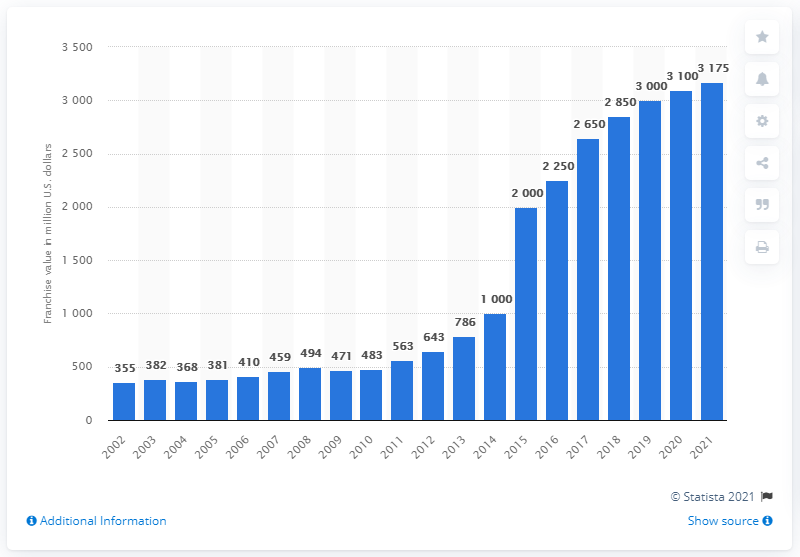Highlight a few significant elements in this photo. In 2021, the estimated value of the San Francisco Giants was 3,175. 